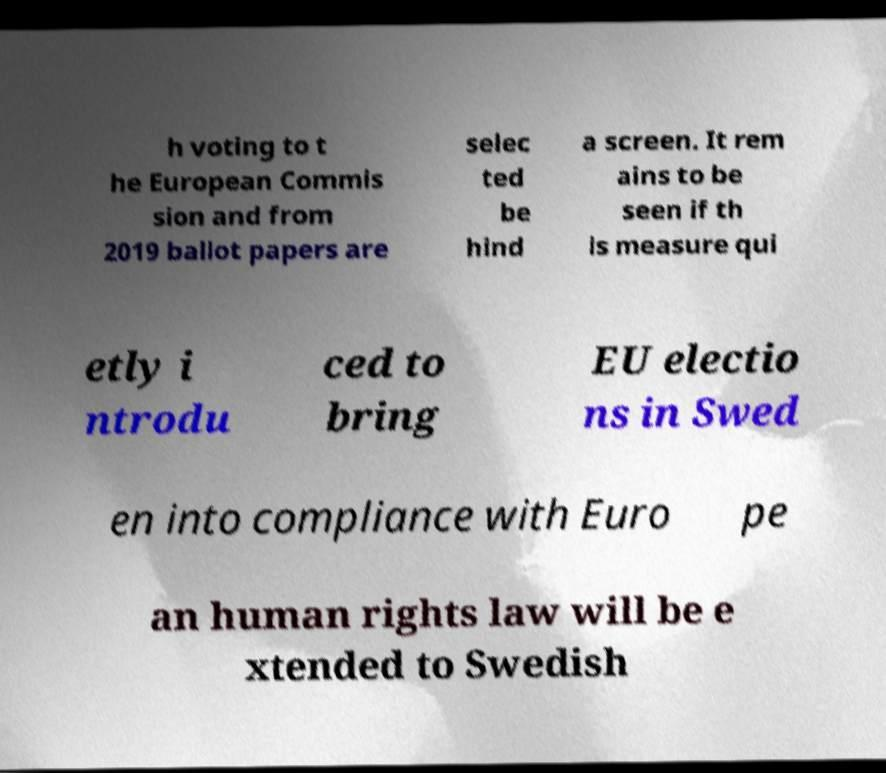Please read and relay the text visible in this image. What does it say? h voting to t he European Commis sion and from 2019 ballot papers are selec ted be hind a screen. It rem ains to be seen if th is measure qui etly i ntrodu ced to bring EU electio ns in Swed en into compliance with Euro pe an human rights law will be e xtended to Swedish 